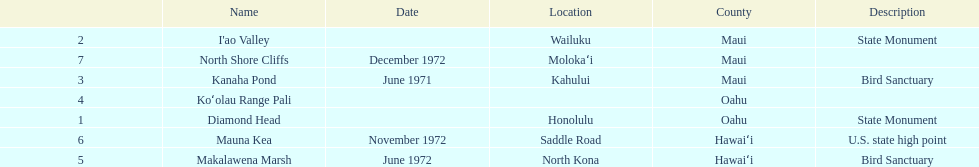Could you parse the entire table as a dict? {'header': ['', 'Name', 'Date', 'Location', 'County', 'Description'], 'rows': [['2', "I'ao Valley", '', 'Wailuku', 'Maui', 'State Monument'], ['7', 'North Shore Cliffs', 'December 1972', 'Molokaʻi', 'Maui', ''], ['3', 'Kanaha Pond', 'June 1971', 'Kahului', 'Maui', 'Bird Sanctuary'], ['4', 'Koʻolau Range Pali', '', '', 'Oahu', ''], ['1', 'Diamond Head', '', 'Honolulu', 'Oahu', 'State Monument'], ['6', 'Mauna Kea', 'November 1972', 'Saddle Road', 'Hawaiʻi', 'U.S. state high point'], ['5', 'Makalawena Marsh', 'June 1972', 'North Kona', 'Hawaiʻi', 'Bird Sanctuary']]} What is the number of bird sanctuary landmarks? 2. 